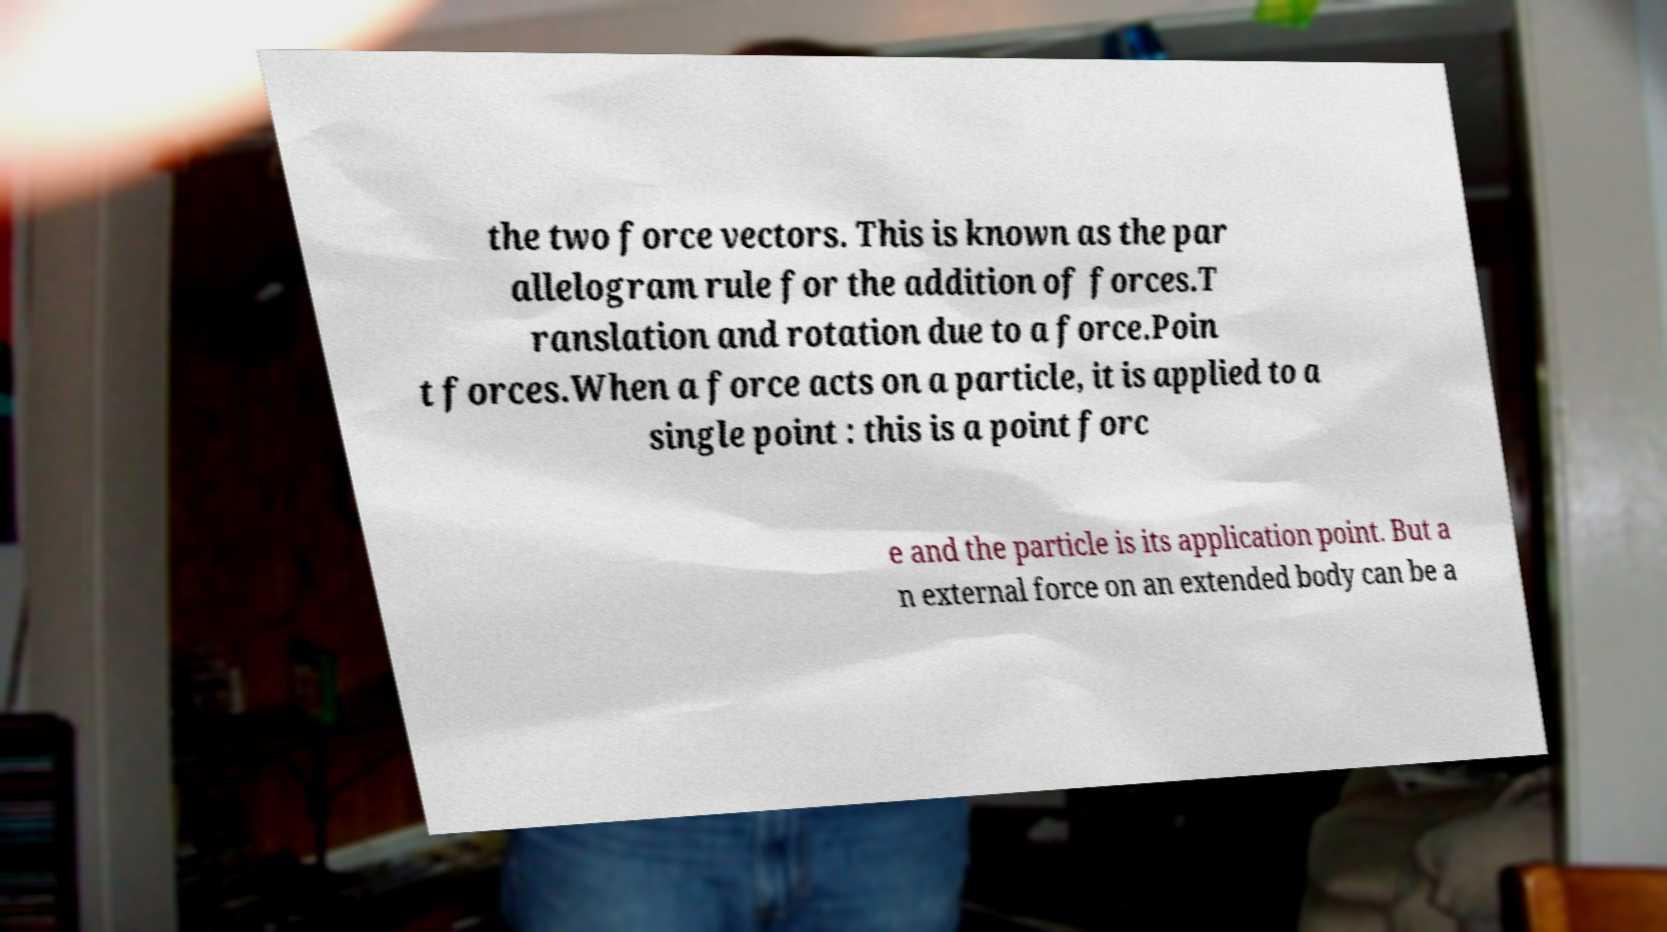What messages or text are displayed in this image? I need them in a readable, typed format. the two force vectors. This is known as the par allelogram rule for the addition of forces.T ranslation and rotation due to a force.Poin t forces.When a force acts on a particle, it is applied to a single point : this is a point forc e and the particle is its application point. But a n external force on an extended body can be a 